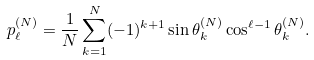Convert formula to latex. <formula><loc_0><loc_0><loc_500><loc_500>p _ { \ell } ^ { ( N ) } = \frac { 1 } { N } \sum _ { k = 1 } ^ { N } ( - 1 ) ^ { k + 1 } \sin \theta _ { k } ^ { ( N ) } \cos ^ { \ell - 1 } \theta _ { k } ^ { ( N ) } .</formula> 